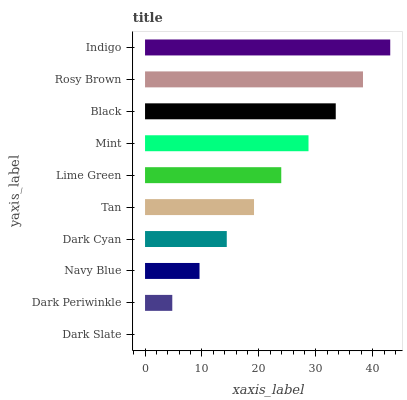Is Dark Slate the minimum?
Answer yes or no. Yes. Is Indigo the maximum?
Answer yes or no. Yes. Is Dark Periwinkle the minimum?
Answer yes or no. No. Is Dark Periwinkle the maximum?
Answer yes or no. No. Is Dark Periwinkle greater than Dark Slate?
Answer yes or no. Yes. Is Dark Slate less than Dark Periwinkle?
Answer yes or no. Yes. Is Dark Slate greater than Dark Periwinkle?
Answer yes or no. No. Is Dark Periwinkle less than Dark Slate?
Answer yes or no. No. Is Lime Green the high median?
Answer yes or no. Yes. Is Tan the low median?
Answer yes or no. Yes. Is Dark Periwinkle the high median?
Answer yes or no. No. Is Indigo the low median?
Answer yes or no. No. 